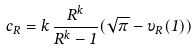<formula> <loc_0><loc_0><loc_500><loc_500>c _ { R } = k \, \frac { R ^ { k } } { R ^ { k } - 1 } ( \sqrt { \pi } - \upsilon _ { R } ( 1 ) )</formula> 